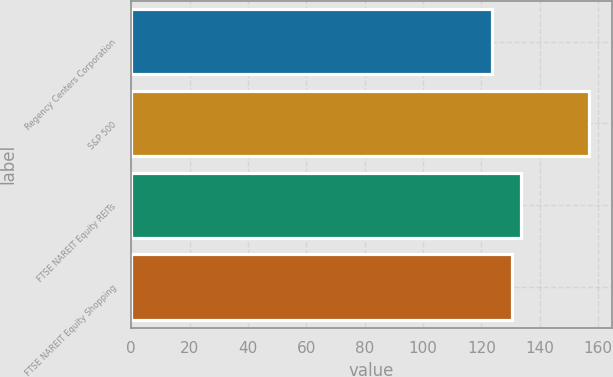Convert chart to OTSL. <chart><loc_0><loc_0><loc_500><loc_500><bar_chart><fcel>Regency Centers Corporation<fcel>S&P 500<fcel>FTSE NAREIT Equity REITs<fcel>FTSE NAREIT Equity Shopping<nl><fcel>123.64<fcel>156.82<fcel>133.63<fcel>130.31<nl></chart> 